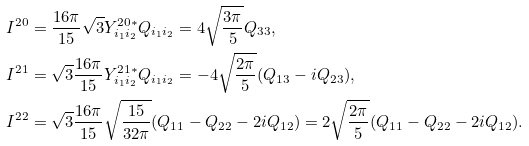Convert formula to latex. <formula><loc_0><loc_0><loc_500><loc_500>I ^ { 2 0 } & = \frac { 1 6 \pi } { 1 5 } \sqrt { 3 } Y ^ { 2 0 \ast } _ { i _ { 1 } i _ { 2 } } Q _ { i _ { 1 } i _ { 2 } } = 4 \sqrt { \frac { 3 \pi } { 5 } } Q _ { 3 3 } , \\ I ^ { 2 1 } & = \sqrt { 3 } \frac { 1 6 \pi } { 1 5 } Y ^ { 2 1 \ast } _ { i _ { 1 } i _ { 2 } } Q _ { i _ { 1 } i _ { 2 } } = - 4 \sqrt { \frac { 2 \pi } { 5 } } ( Q _ { 1 3 } - i Q _ { 2 3 } ) , \\ I ^ { 2 2 } & = \sqrt { 3 } \frac { 1 6 \pi } { 1 5 } \sqrt { \frac { 1 5 } { 3 2 \pi } } ( Q _ { 1 1 } - Q _ { 2 2 } - 2 i Q _ { 1 2 } ) = 2 \sqrt { \frac { 2 \pi } { 5 } } ( Q _ { 1 1 } - Q _ { 2 2 } - 2 i Q _ { 1 2 } ) .</formula> 